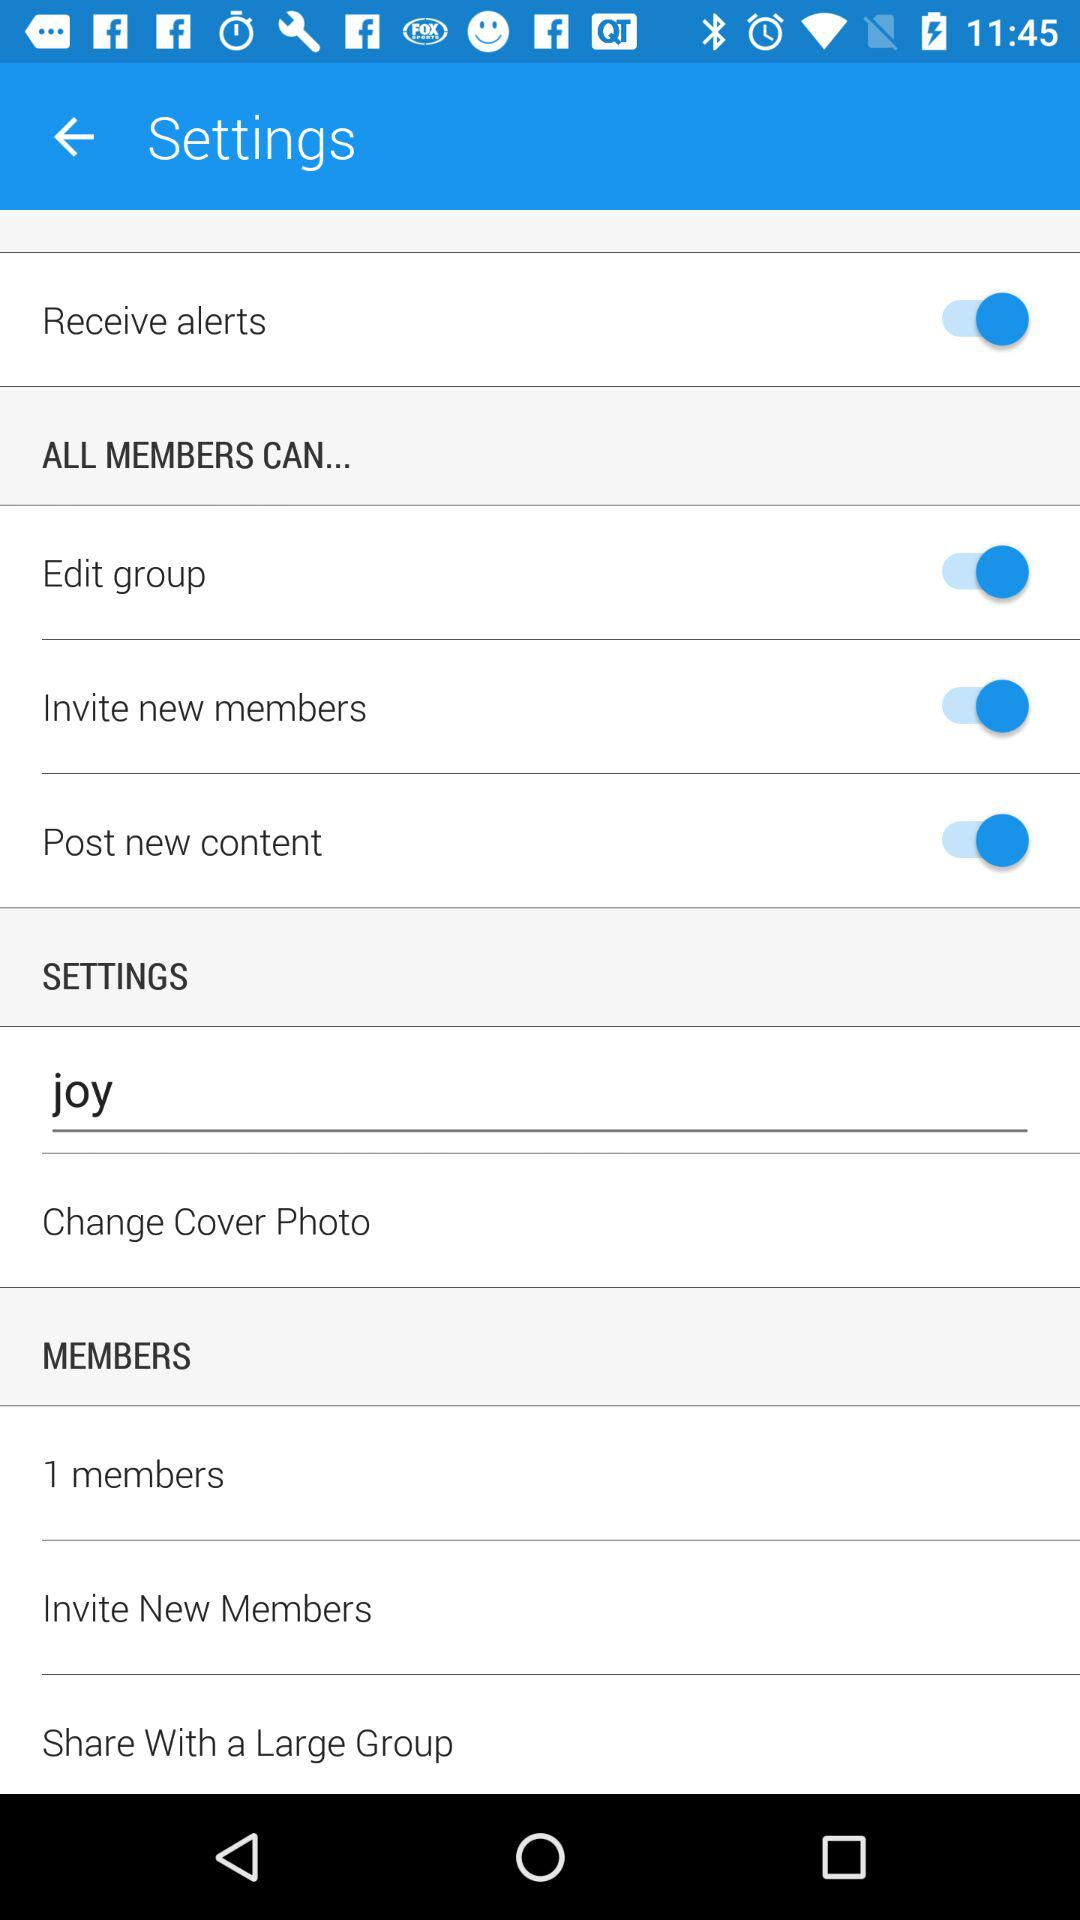How many members are in the group?
Answer the question using a single word or phrase. 1 